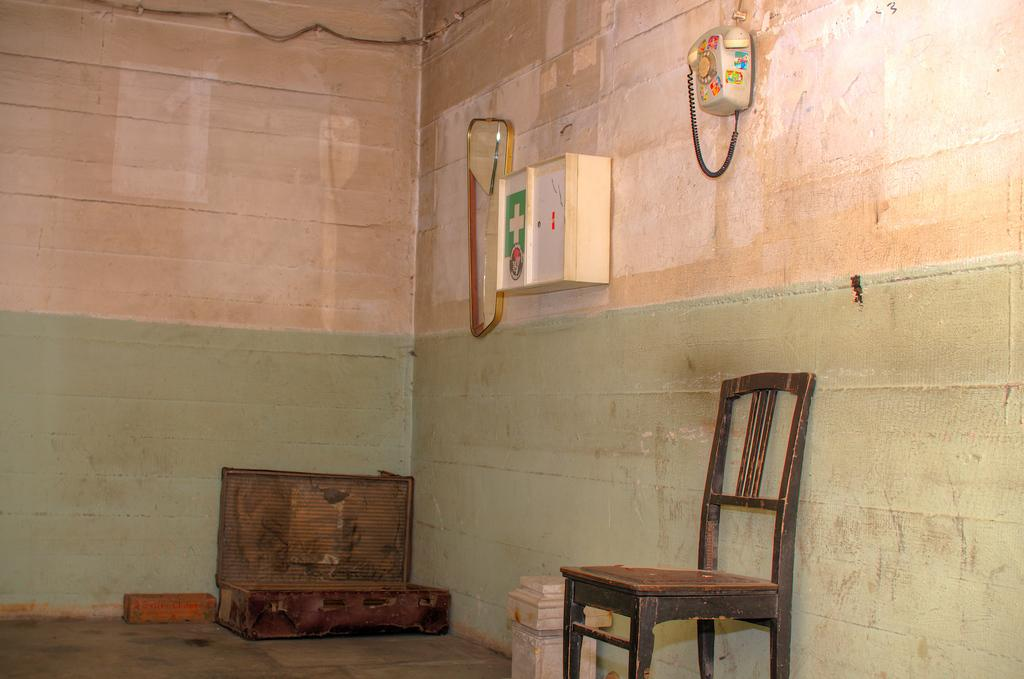What type of chair is in the image? There is a black chair in the image. What is on the floor in the image? There is a box on the floor, as well as other unspecified items. What can be seen on the wall in the image? There is a mirror and a white first aid box on the wall. What device is present in the image for communication? There is a telephone in the image. Can you see a nest in the image? There is no nest present in the image. Is there any milk visible in the image? There is no milk visible in the image. 